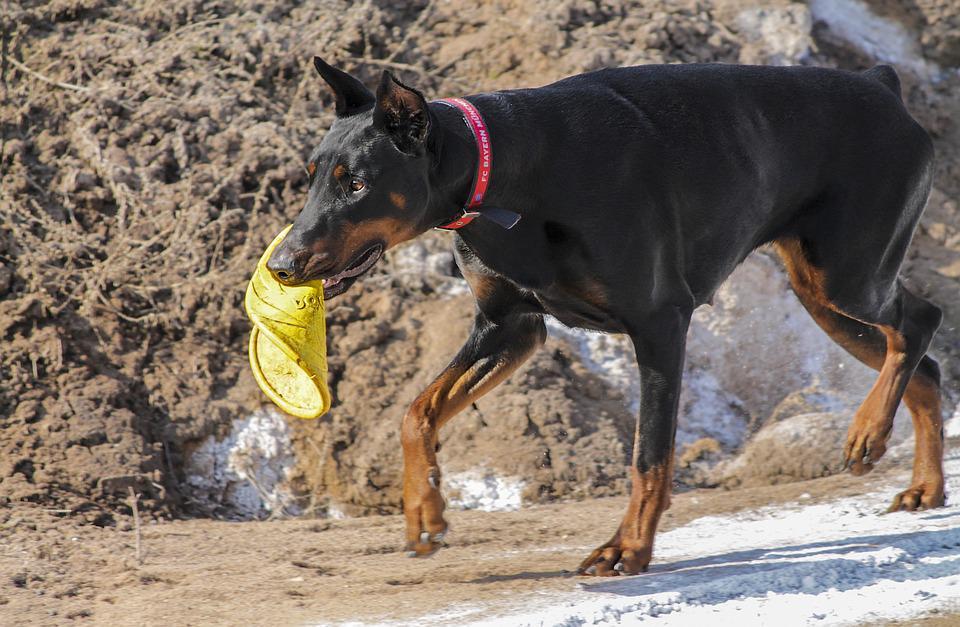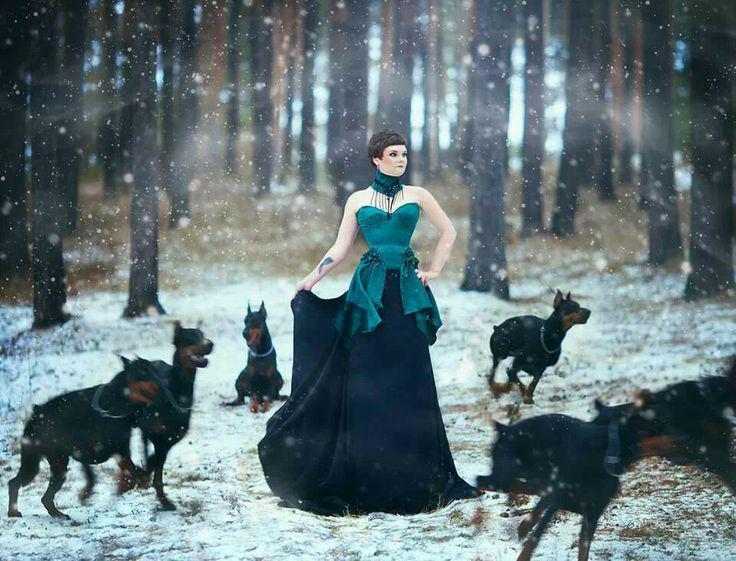The first image is the image on the left, the second image is the image on the right. For the images shown, is this caption "An image shows a person at the center of an outdoor scene, surrounded by a group of pointy-eared adult dobermans wearing collars." true? Answer yes or no. Yes. The first image is the image on the left, the second image is the image on the right. Evaluate the accuracy of this statement regarding the images: "There are more dogs in the left image than in the right image.". Is it true? Answer yes or no. No. 